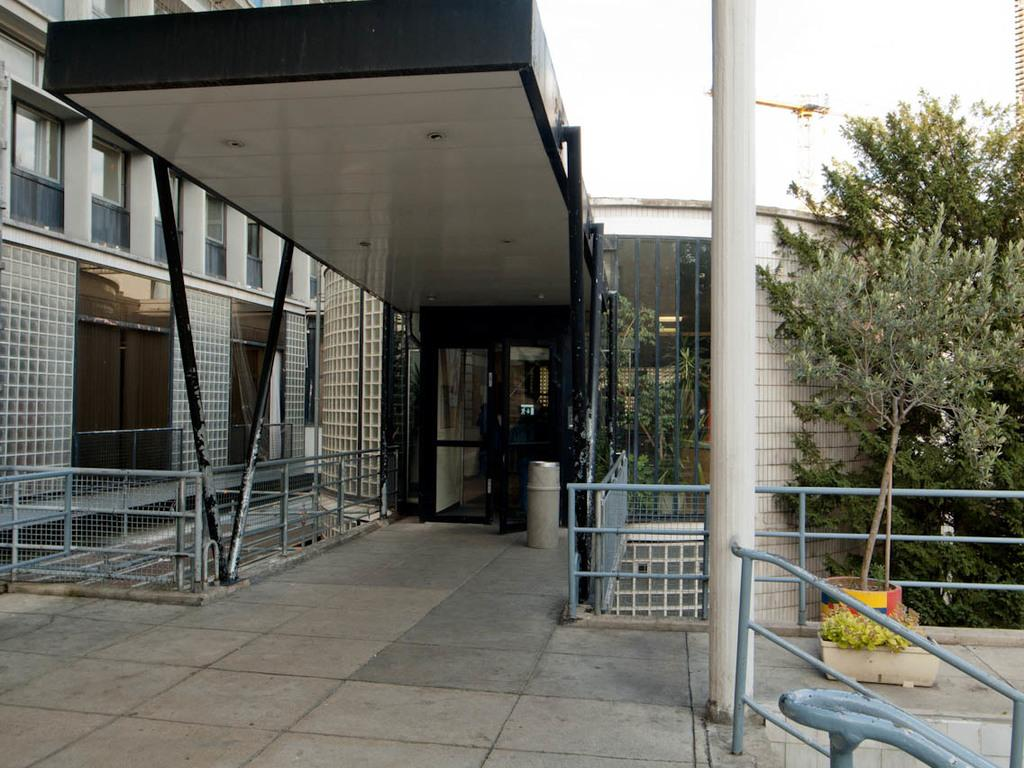What type of structure is visible in the image? There is a building in the image. What architectural features can be seen on the building? There are pillars visible on the building. What type of vegetation is on the right side of the image? There are trees on the right side of the image. What is located near the trees on the right side of the image? There is a plant pot on the right side of the image. What safety feature can be seen in the image? There is a railing in the image. What color is the father's eye in the image? There is no father or eye present in the image. How does the tramp interact with the building in the image? There is no tramp present in the image, so it is not possible to determine how they might interact with the building. 